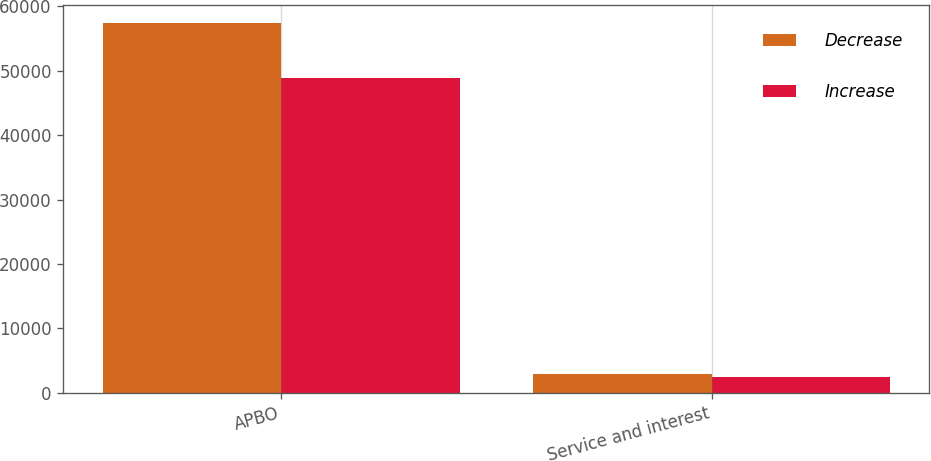Convert chart to OTSL. <chart><loc_0><loc_0><loc_500><loc_500><stacked_bar_chart><ecel><fcel>APBO<fcel>Service and interest<nl><fcel>Decrease<fcel>57329<fcel>2926<nl><fcel>Increase<fcel>48831<fcel>2477<nl></chart> 